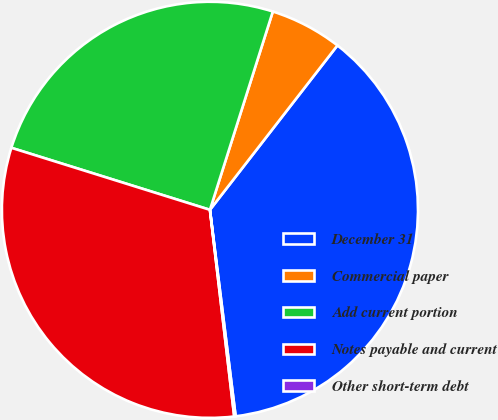Convert chart to OTSL. <chart><loc_0><loc_0><loc_500><loc_500><pie_chart><fcel>December 31<fcel>Commercial paper<fcel>Add current portion<fcel>Notes payable and current<fcel>Other short-term debt<nl><fcel>37.53%<fcel>5.61%<fcel>25.07%<fcel>31.68%<fcel>0.11%<nl></chart> 